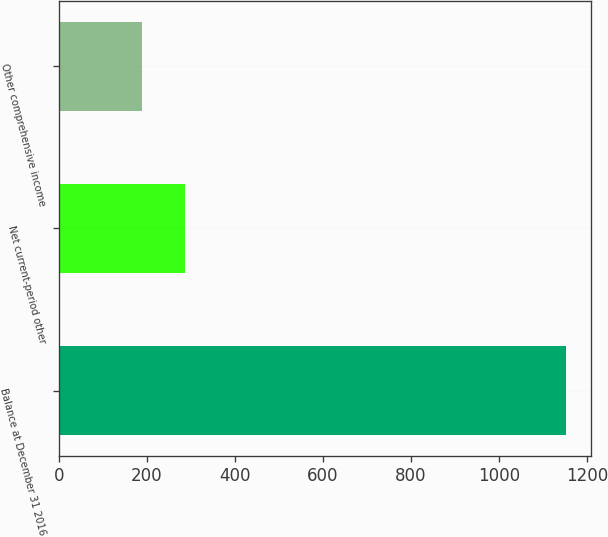Convert chart to OTSL. <chart><loc_0><loc_0><loc_500><loc_500><bar_chart><fcel>Balance at December 31 2016<fcel>Net current-period other<fcel>Other comprehensive income<nl><fcel>1153<fcel>286.3<fcel>190<nl></chart> 